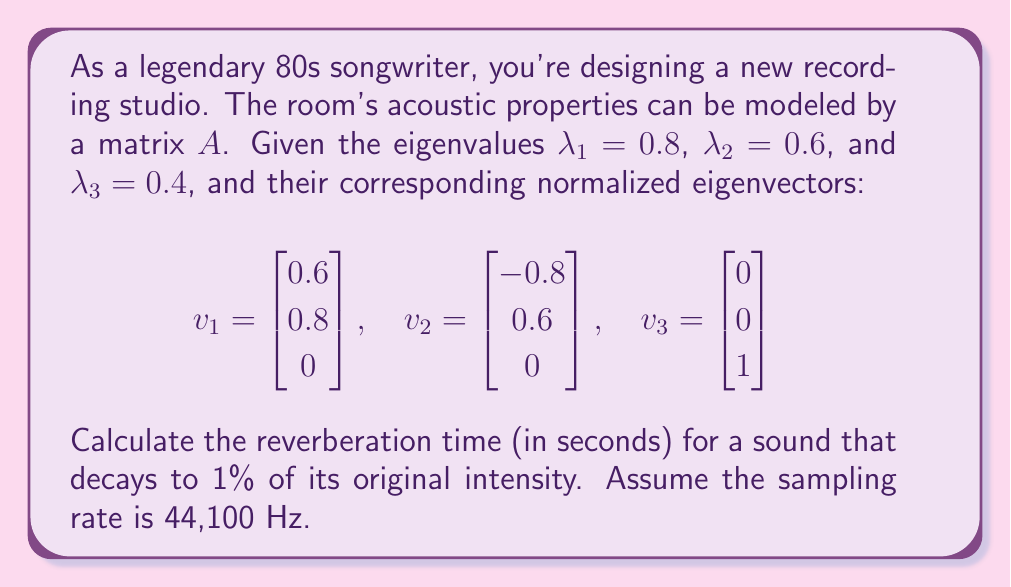Solve this math problem. Let's approach this step-by-step:

1) The reverberation time is related to the decay of sound energy in the room. The eigenvalues of matrix $A$ represent the decay factors for different modes of sound in the room.

2) The slowest decaying mode will dominate the overall reverberation time. This corresponds to the largest eigenvalue, which is $\lambda_1 = 0.8$.

3) For each time step, the energy is multiplied by $\lambda_1^2 = 0.8^2 = 0.64$. This is because energy is proportional to the square of the amplitude.

4) We need to find how many steps it takes for the energy to decay to 1% of its original value. Let's call this number of steps $n$. We can express this as an equation:

   $$(0.64)^n = 0.01$$

5) Taking the natural log of both sides:

   $$n \ln(0.64) = \ln(0.01)$$

6) Solving for $n$:

   $$n = \frac{\ln(0.01)}{\ln(0.64)} \approx 10.38$$

7) Now, we need to convert this to time. Given the sampling rate of 44,100 Hz, each time step is $\frac{1}{44100}$ seconds.

8) The reverberation time $T$ in seconds is therefore:

   $$T = \frac{10.38}{44100} \approx 0.000235 \text{ seconds}$$
Answer: 0.000235 seconds 